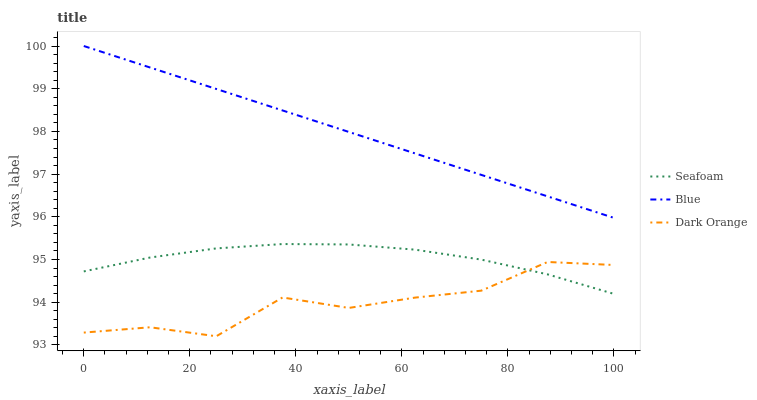Does Seafoam have the minimum area under the curve?
Answer yes or no. No. Does Seafoam have the maximum area under the curve?
Answer yes or no. No. Is Seafoam the smoothest?
Answer yes or no. No. Is Seafoam the roughest?
Answer yes or no. No. Does Seafoam have the lowest value?
Answer yes or no. No. Does Seafoam have the highest value?
Answer yes or no. No. Is Dark Orange less than Blue?
Answer yes or no. Yes. Is Blue greater than Seafoam?
Answer yes or no. Yes. Does Dark Orange intersect Blue?
Answer yes or no. No. 